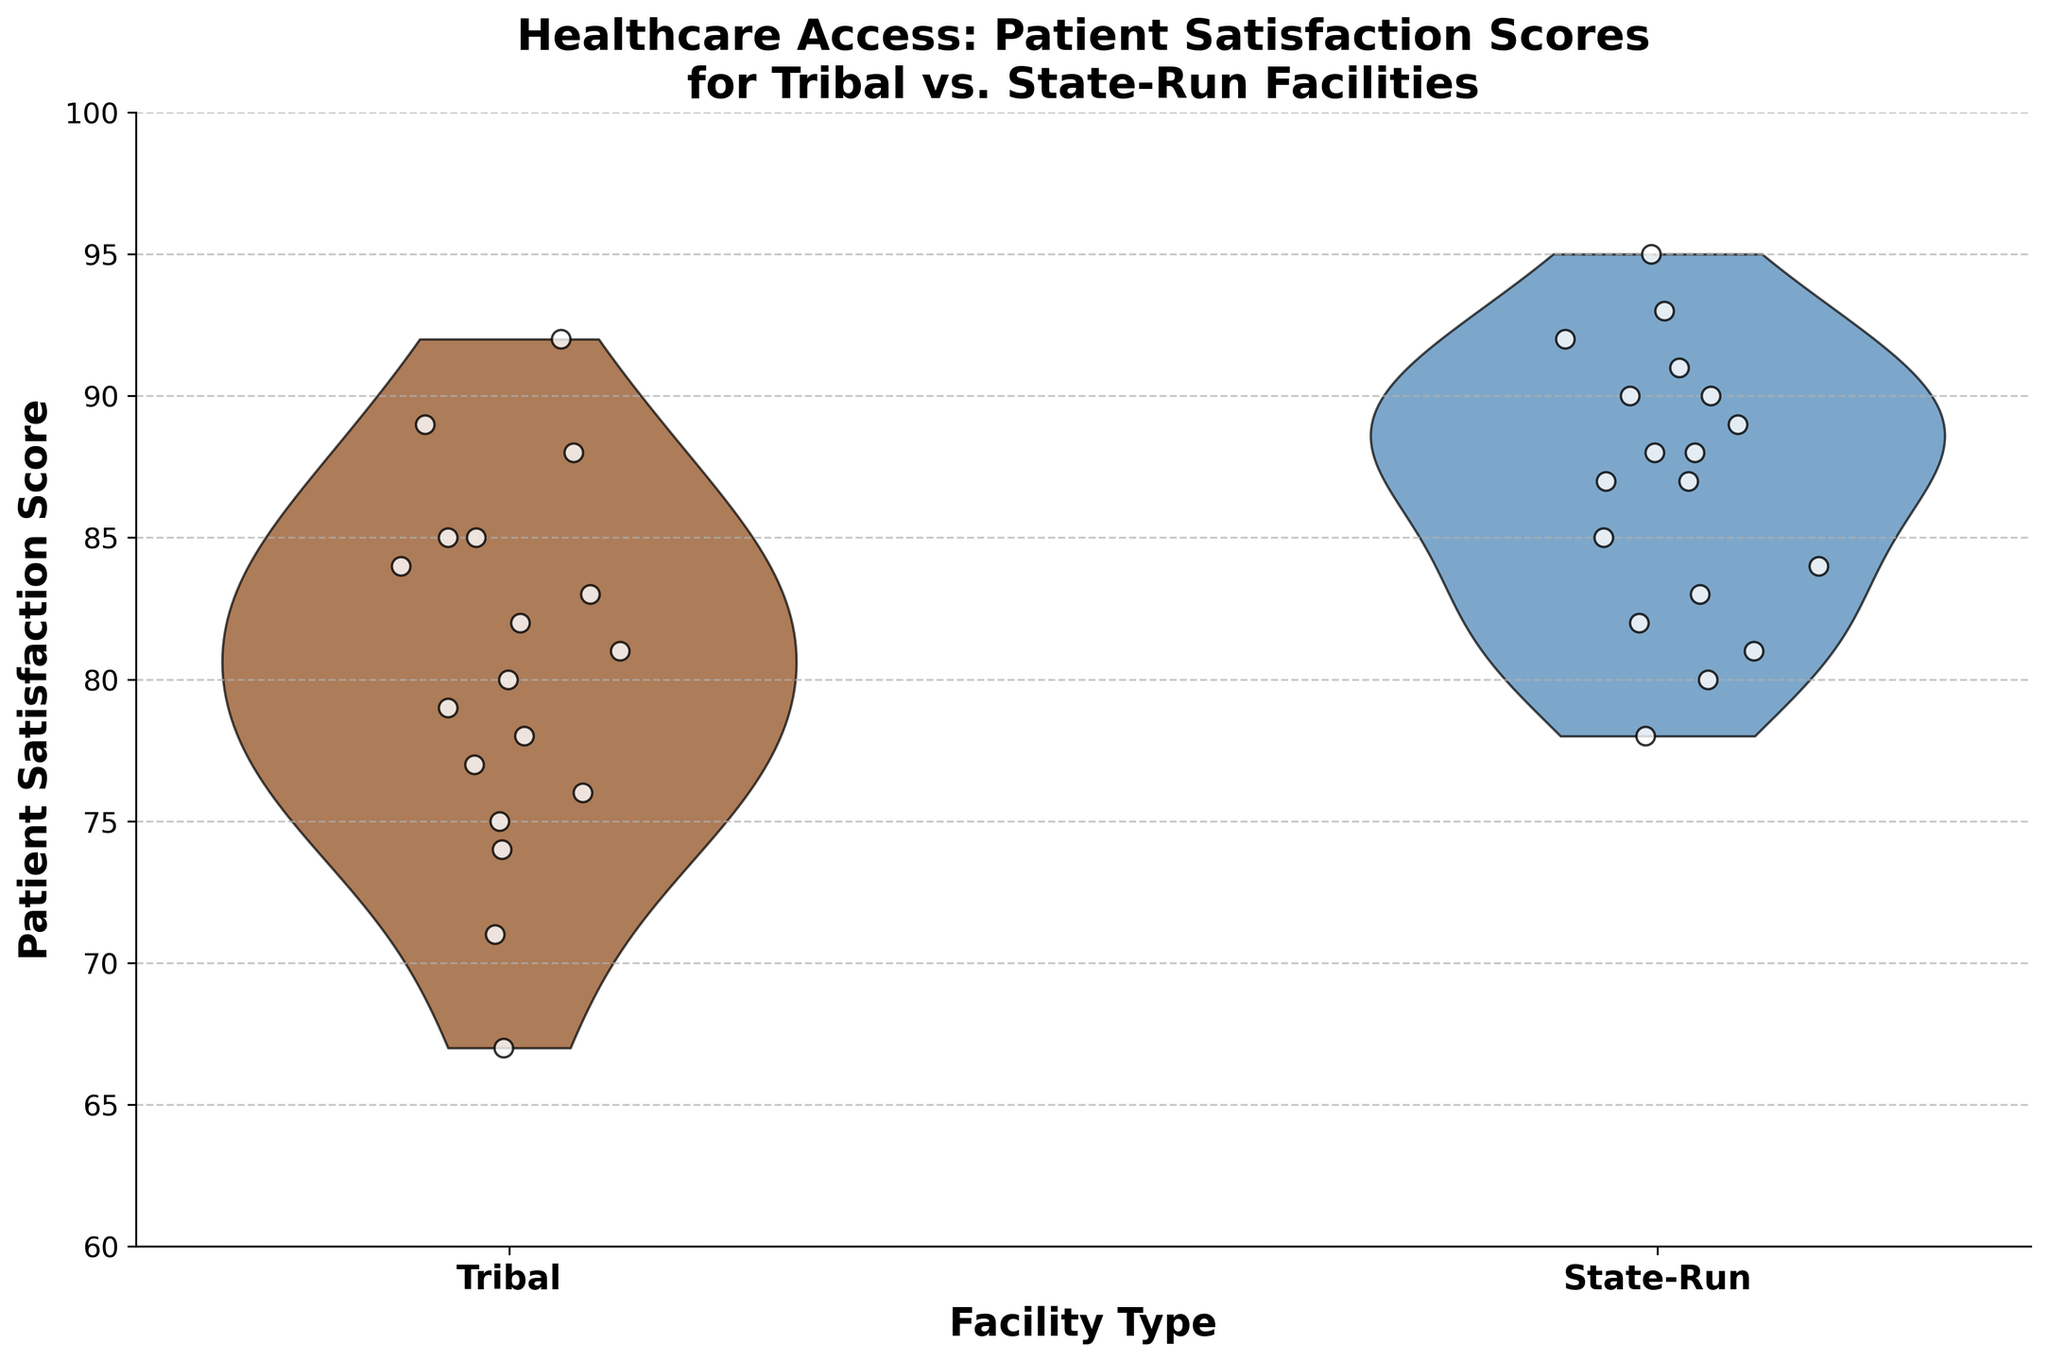How many facility types are compared in the figure? The x-axis in the figure has two categories labeled "Tribal" and "State-Run." These labels indicate the facility types being compared.
Answer: 2 What is the maximum patient satisfaction score displayed for state-run facilities? Jittered points and the violin shape's upper edge indicate the maximum score. For state-run facilities, the highest point is at the top of the violin plot, reaching up to 95.
Answer: 95 Which facility type shows a wider range of patient satisfaction scores? Observing the x-axis categories "Tribal" and "State-Run," and noting the spread of the jittered points, we see that "Tribal" facilities have points spread between 67 and 92, compared to "State-Run" facilities spread between 78 and 95. "Tribal" thus shows a wider range.
Answer: Tribal What's the median patient satisfaction score for tribal facilities? Median values are typically shown by the central tendency in the violin plot. The center of the spread for the "Tribal" group appears around 80 from visual inspection.
Answer: 80 Which facility type has the highest density of patient satisfaction scores in the 80-90 range? The violin plot's thickness within the 80-90 score range indicates density. "State-Run" facilities show a thicker plot between these values, suggesting a higher density compared to "Tribal" facilities.
Answer: State-Run Are there more data points above 90 in state-run facilities or tribal facilities? By counting the jittered points above the 90 mark in each category, "State-Run" facilities show more points above 90 compared to "Tribal" facilities, which has only one point at 92.
Answer: State-Run What is the most common patient satisfaction score range for state-run facilities? The overall shape of the state-run violin plot indicates the most common score range. The plot widens significantly between 85-90, indicating most points fall in this range.
Answer: 85-90 What’s the difference between the average patient satisfaction score for tribal and state-run facilities? To estimate this, note the general central tendencies of both groups. "Tribal" facilities average around 80, and "State-Run" facilities average around 88. The difference is approximately 88 - 80.
Answer: 8 Which facility type has the higher lowest patient satisfaction score? Observing the bottom edge of the violins and jittered points, the lowest score for "Tribal" facilities is around 67, while for "State-Run" facilities, it is around 78. Therefore, "State-Run" has the higher lowest score.
Answer: State-Run 